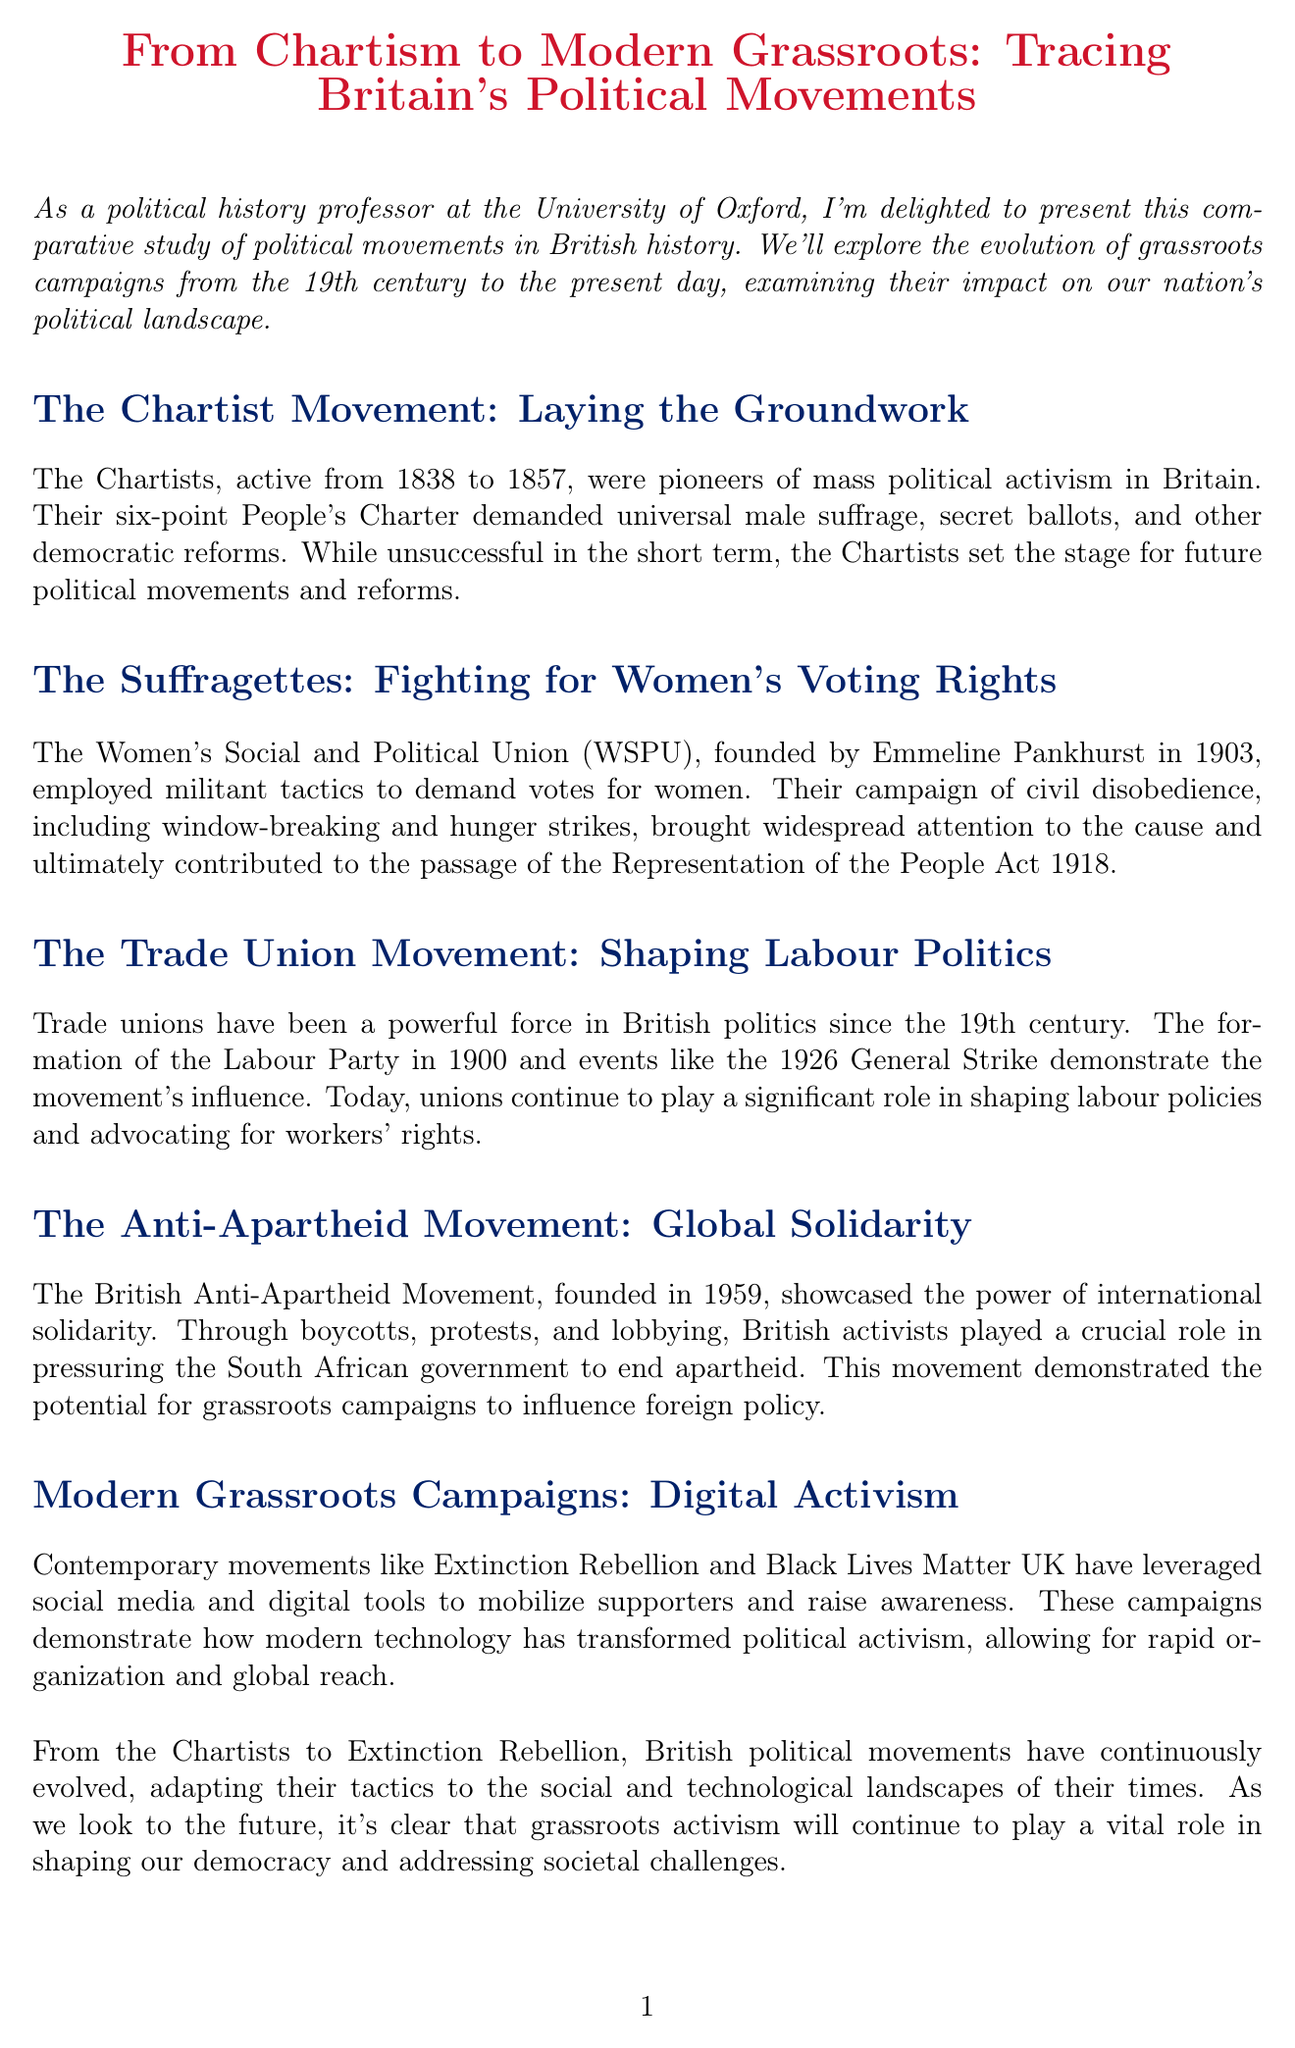What years did the Chartist Movement occur? The document states that the Chartists were active from 1838 to 1857.
Answer: 1838 to 1857 Who founded the Women's Social and Political Union? The document mentions that Emmeline Pankhurst founded the WSPU in 1903.
Answer: Emmeline Pankhurst What significant act was passed in 1918? The document refers to the Representation of the People Act 1918 as a key event resulting from the suffragette movement.
Answer: Representation of the People Act 1918 When was the Labour Party formed? The document states that the Labour Party was formed in 1900.
Answer: 1900 What strategy did the Anti-Apartheid Movement employ? The document highlights that boycotts, protests, and lobbying were key strategies used by the Anti-Apartheid Movement.
Answer: Boycotts, protests, and lobbying What is one modern movement mentioned in the document? The document lists Extinction Rebellion as a contemporary grassroots campaign.
Answer: Extinction Rebellion How many years did the Trade Union Movement influence British politics, according to the document? The document indicates that the Trade Union Movement has been influential since the 19th century, spanning over 200 years up to 2023.
Answer: Over 200 years Which social media metrics are compared in the document? The document mentions a comparative chart of social media engagement metrics for major UK grassroots campaigns.
Answer: Social media engagement metrics What type of activism is referenced as having evolved in modern times? The document refers to digital activism as a key development in modern grassroots campaigns.
Answer: Digital activism 